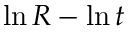Convert formula to latex. <formula><loc_0><loc_0><loc_500><loc_500>\ln { R } - \ln { t }</formula> 